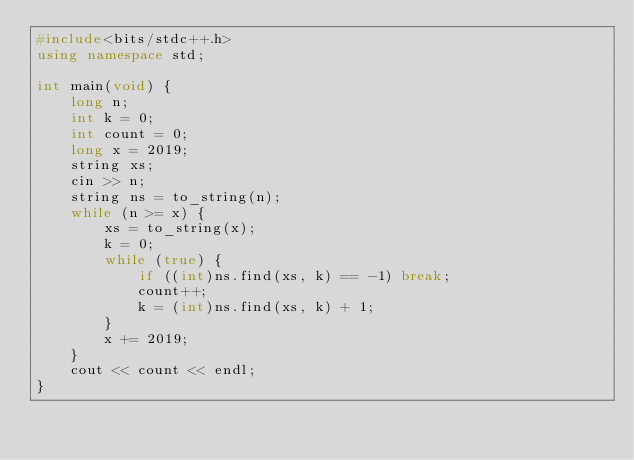Convert code to text. <code><loc_0><loc_0><loc_500><loc_500><_C++_>#include<bits/stdc++.h>
using namespace std;

int main(void) {
    long n;
    int k = 0;
    int count = 0;
    long x = 2019;
    string xs;
    cin >> n;
    string ns = to_string(n);
    while (n >= x) {
        xs = to_string(x);
        k = 0;
        while (true) {
            if ((int)ns.find(xs, k) == -1) break;
            count++;
            k = (int)ns.find(xs, k) + 1;
        }
        x += 2019;
    }
    cout << count << endl;
}</code> 